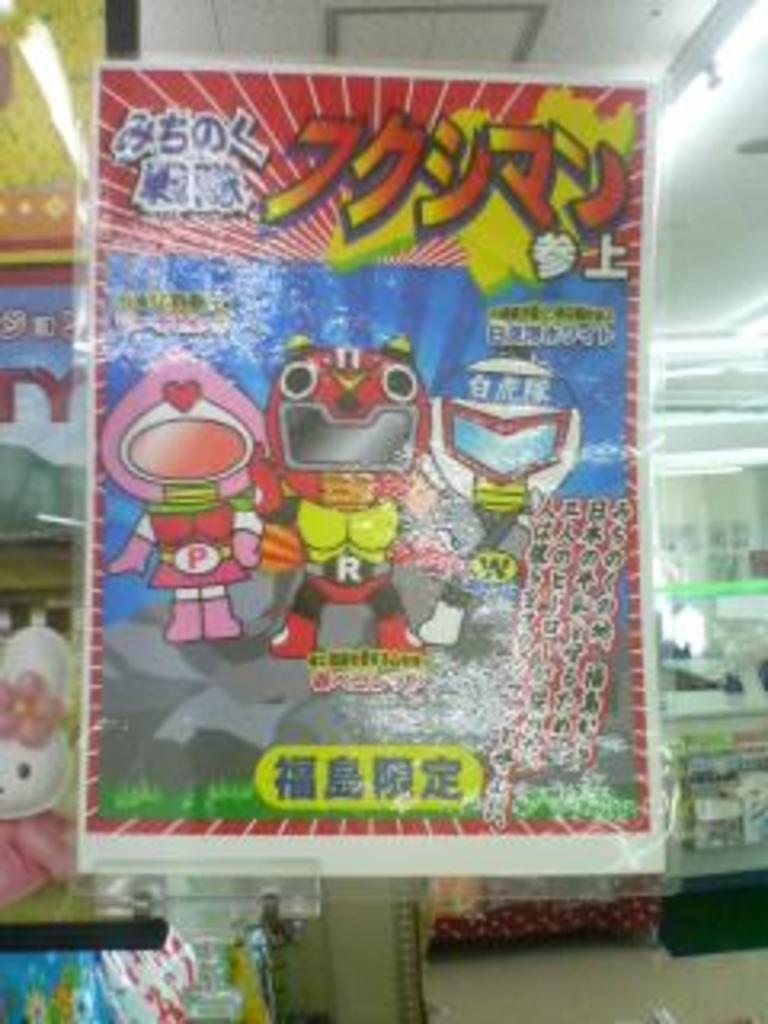Could you give a brief overview of what you see in this image? There is a poster with some animation pictures and something is written. In the back there are toys. On the ceiling there are lights. 